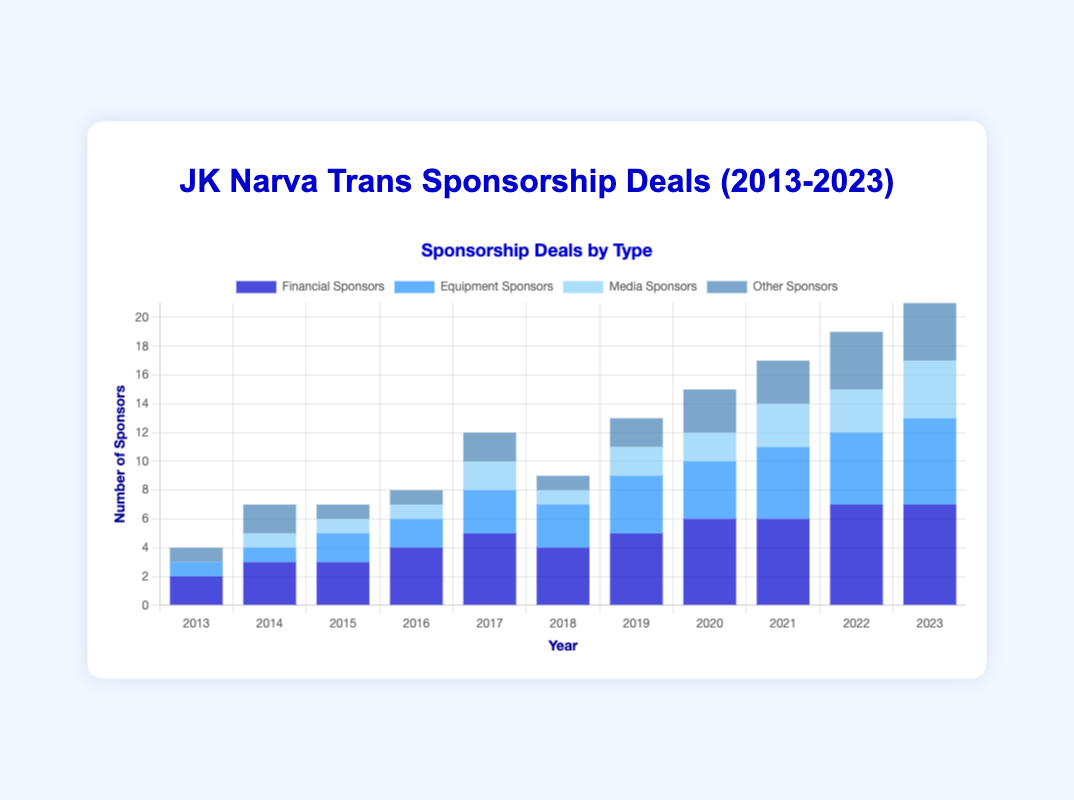Which year had the highest total number of sponsors? Look at each year's bar segments, sum them up, and find the year with the highest total. In 2023, the total sponsors are 7 (financial) + 6 (equipment) + 4 (media) + 4 (other) = 21, which is the highest.
Answer: 2023 How many equipment sponsors were there in 2017 compared to 2013? Check the height of the light blue bar for equipment sponsors in both years. In 2013, there was 1 equipment sponsor and in 2017 there were 3.
Answer: 3 in 2017, 1 in 2013 What is the total number of financial sponsors in 2020, 2021, and 2022 combined? Add the number of financial sponsors for these years: 6 (2020) + 6 (2021) + 7 (2022) = 19.
Answer: 19 Which type of sponsor was consistently present from 2013 to 2023? Financial sponsors have bars (of varying heights) in every year from 2013 to 2023.
Answer: Financial sponsors What is the difference in the number of media sponsors between 2015 and 2023? In 2015, there was 1 media sponsor, and in 2023, there were 4. The difference is 4 - 1 = 3.
Answer: 3 In which year did the dark blue (financial sponsors) bar increase the most compared to the previous year? Compare the height difference of the dark blue bars year by year and find the largest difference. The largest increase is from 2022 to 2023 where it increased from 6 to 7.
Answer: 2022 to 2023 Which year had the least number of total sponsors? Sum the number of sponsors in each year and identify the smallest sum. In 2013, the total is 2 (financial) + 1 (equipment) + 0 (media) + 1 (other) = 4, which is the lowest.
Answer: 2013 How many years had more than 5 equipment sponsors? Find years where the light blue bar (equipment sponsors) exceeds 5. Only 2023 has more than 5 equipment sponsors.
Answer: 1 year What is the average number of other sponsors per year over the decade? Sum the number of other sponsors from 2013 to 2023, then divide by 11. (1+2+1+1+2+1+2+3+3+4+4) = 24, so the average is 24/11 ≈ 2.18.
Answer: Approximately 2.18 Which year had the highest number of media sponsors, and how many were there? Find the highest bar segment for media sponsors (lightest blue). In 2023, there were 4 media sponsors.
Answer: 2023, 4 